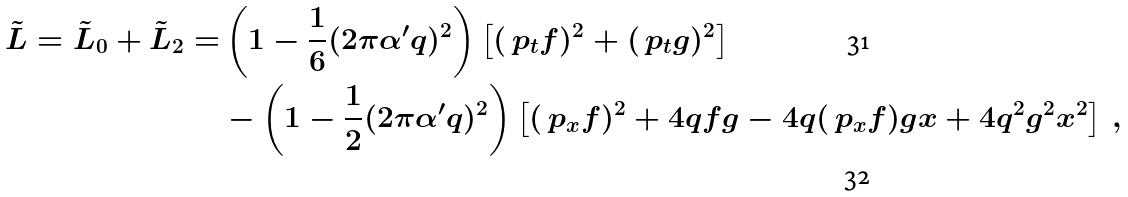Convert formula to latex. <formula><loc_0><loc_0><loc_500><loc_500>\tilde { L } = \tilde { L } _ { 0 } + \tilde { L } _ { 2 } = & \left ( 1 - \frac { 1 } { 6 } ( 2 \pi \alpha ^ { \prime } q ) ^ { 2 } \right ) \left [ ( \ p _ { t } f ) ^ { 2 } + ( \ p _ { t } g ) ^ { 2 } \right ] \\ & - \left ( 1 - \frac { 1 } { 2 } ( 2 \pi \alpha ^ { \prime } q ) ^ { 2 } \right ) \left [ ( \ p _ { x } f ) ^ { 2 } + 4 q f g - 4 q ( \ p _ { x } f ) g x + 4 q ^ { 2 } g ^ { 2 } x ^ { 2 } \right ] \ ,</formula> 